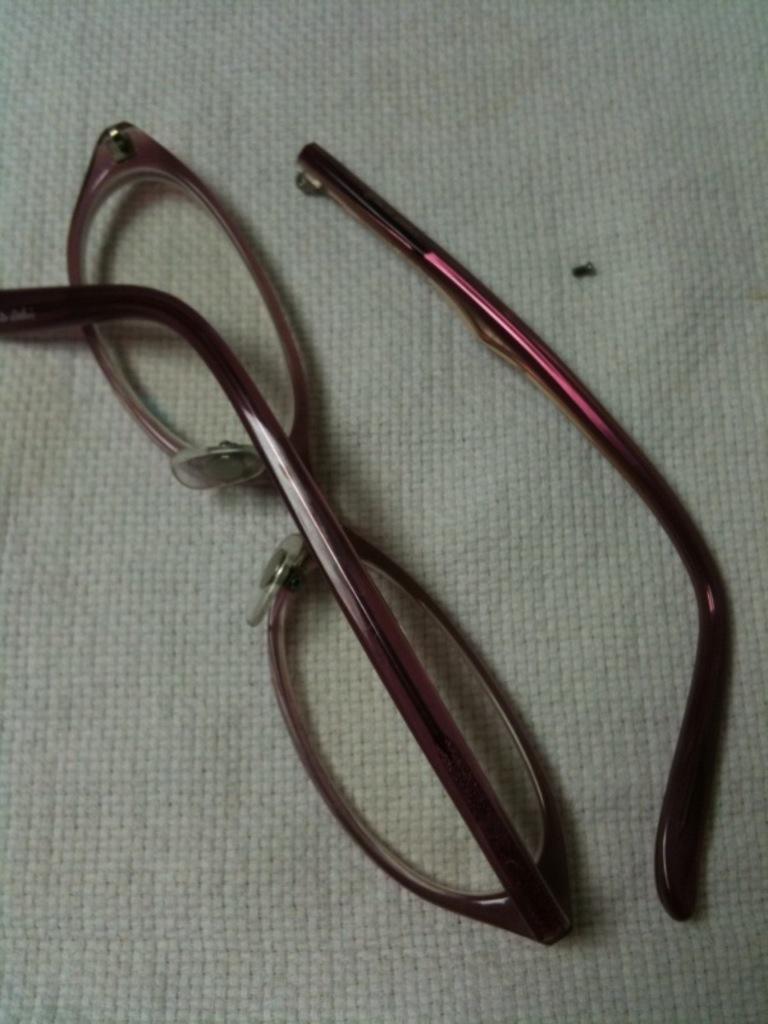How would you summarize this image in a sentence or two? In this image we can see a broken specs with a leg on a white cloth. 